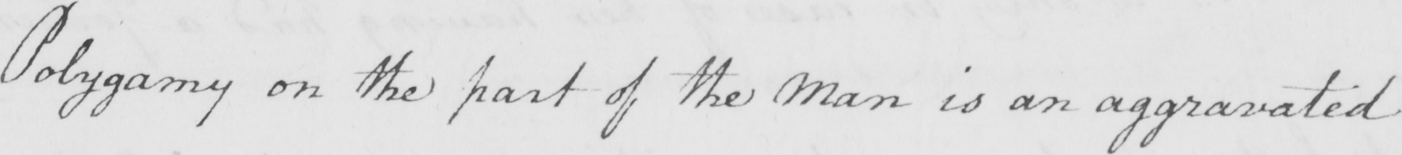Please provide the text content of this handwritten line. Polygamy on the part of the Man is an aggravated 